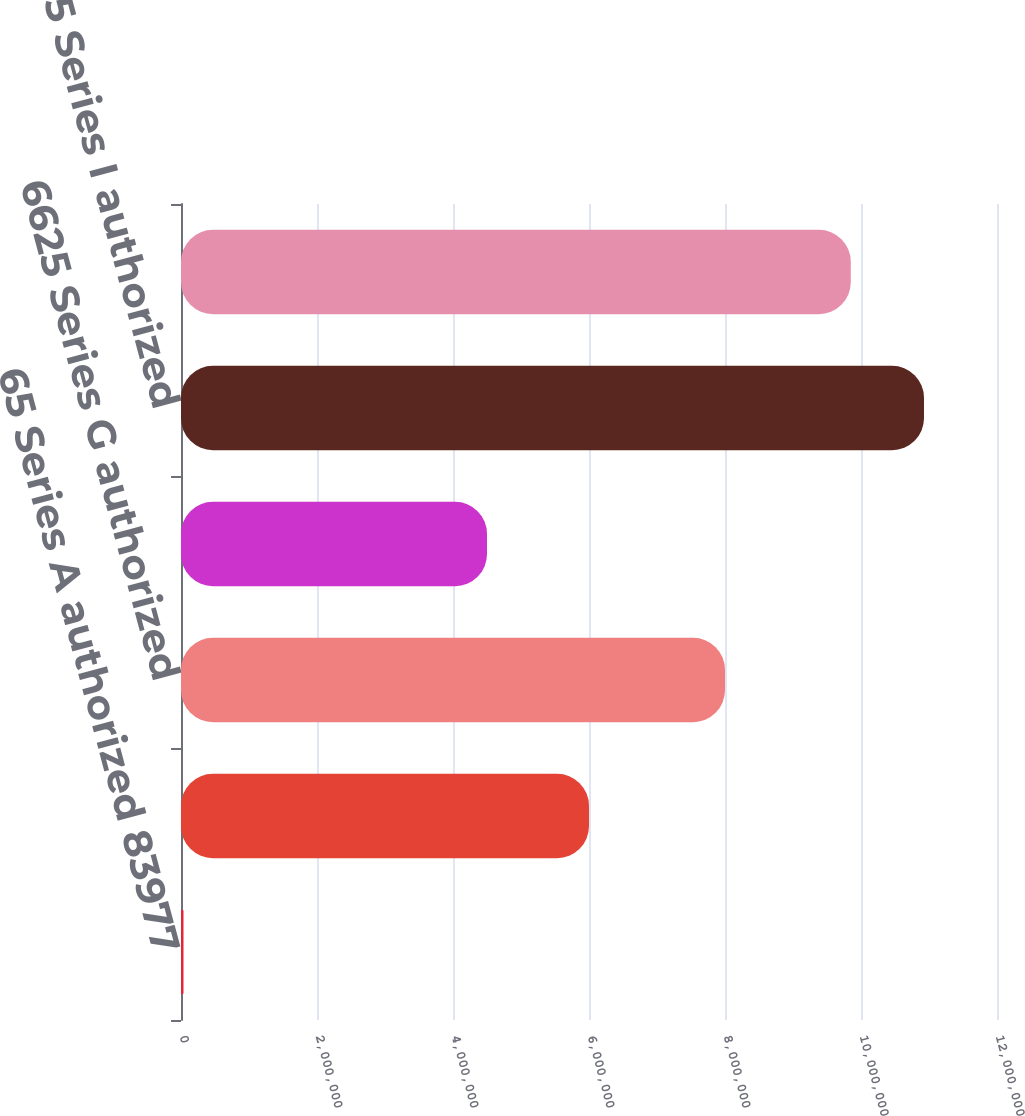<chart> <loc_0><loc_0><loc_500><loc_500><bar_chart><fcel>65 Series A authorized 83977<fcel>675 Series F authorized<fcel>6625 Series G authorized<fcel>675 Series H authorized<fcel>6625 Series I authorized<fcel>6875 Series J authorized<nl><fcel>36709<fcel>6e+06<fcel>8e+06<fcel>4.5e+06<fcel>1.09263e+07<fcel>9.85e+06<nl></chart> 